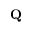Convert formula to latex. <formula><loc_0><loc_0><loc_500><loc_500>Q</formula> 